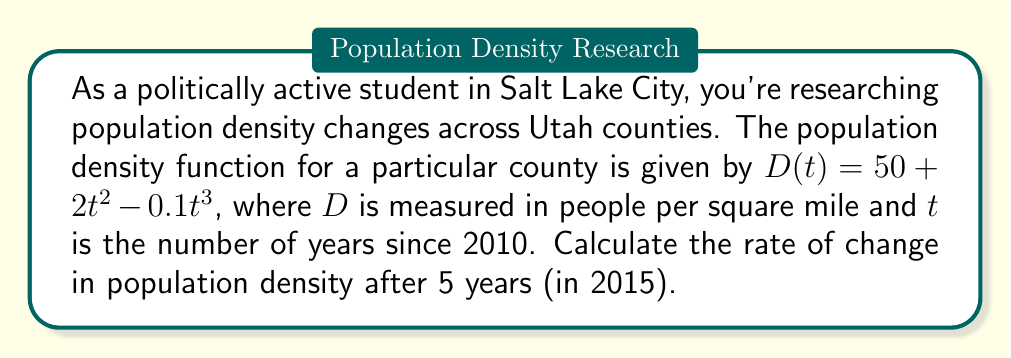Help me with this question. To find the rate of change in population density, we need to calculate the derivative of the given function and evaluate it at $t = 5$.

Step 1: Find the derivative of $D(t)$.
$$\frac{d}{dt}D(t) = \frac{d}{dt}(50 + 2t^2 - 0.1t^3)$$
$$D'(t) = 0 + 4t - 0.3t^2$$

Step 2: Simplify the derivative.
$$D'(t) = 4t - 0.3t^2$$

Step 3: Evaluate $D'(t)$ at $t = 5$.
$$D'(5) = 4(5) - 0.3(5^2)$$
$$D'(5) = 20 - 0.3(25)$$
$$D'(5) = 20 - 7.5$$
$$D'(5) = 12.5$$

The rate of change in population density after 5 years (in 2015) is 12.5 people per square mile per year.
Answer: 12.5 people/mi²/year 